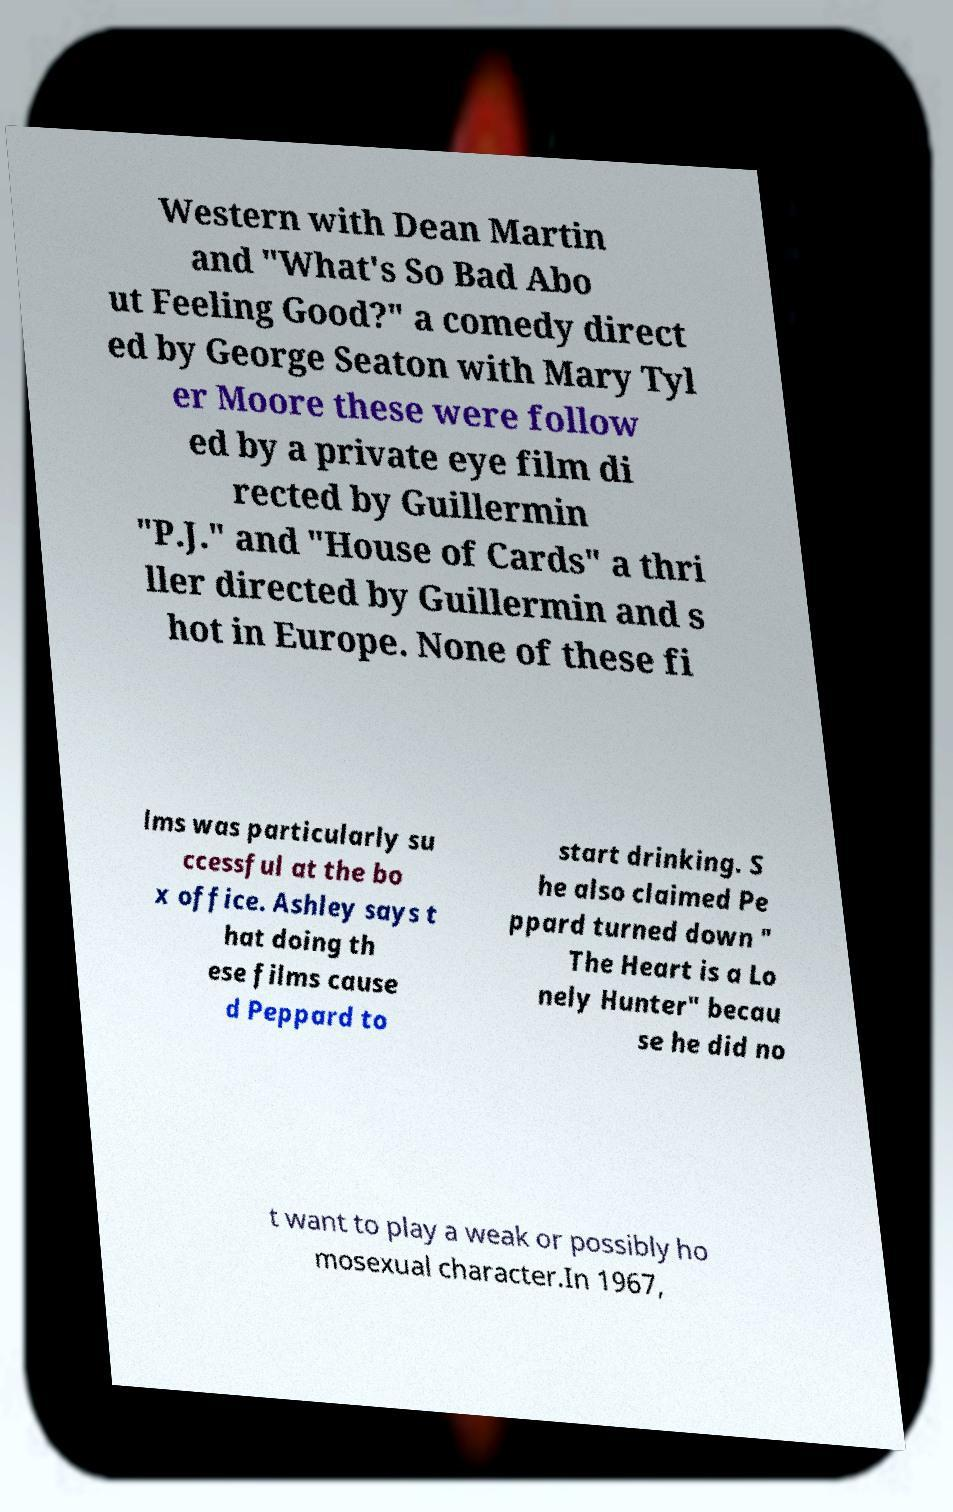Please read and relay the text visible in this image. What does it say? Western with Dean Martin and "What's So Bad Abo ut Feeling Good?" a comedy direct ed by George Seaton with Mary Tyl er Moore these were follow ed by a private eye film di rected by Guillermin "P.J." and "House of Cards" a thri ller directed by Guillermin and s hot in Europe. None of these fi lms was particularly su ccessful at the bo x office. Ashley says t hat doing th ese films cause d Peppard to start drinking. S he also claimed Pe ppard turned down " The Heart is a Lo nely Hunter" becau se he did no t want to play a weak or possibly ho mosexual character.In 1967, 